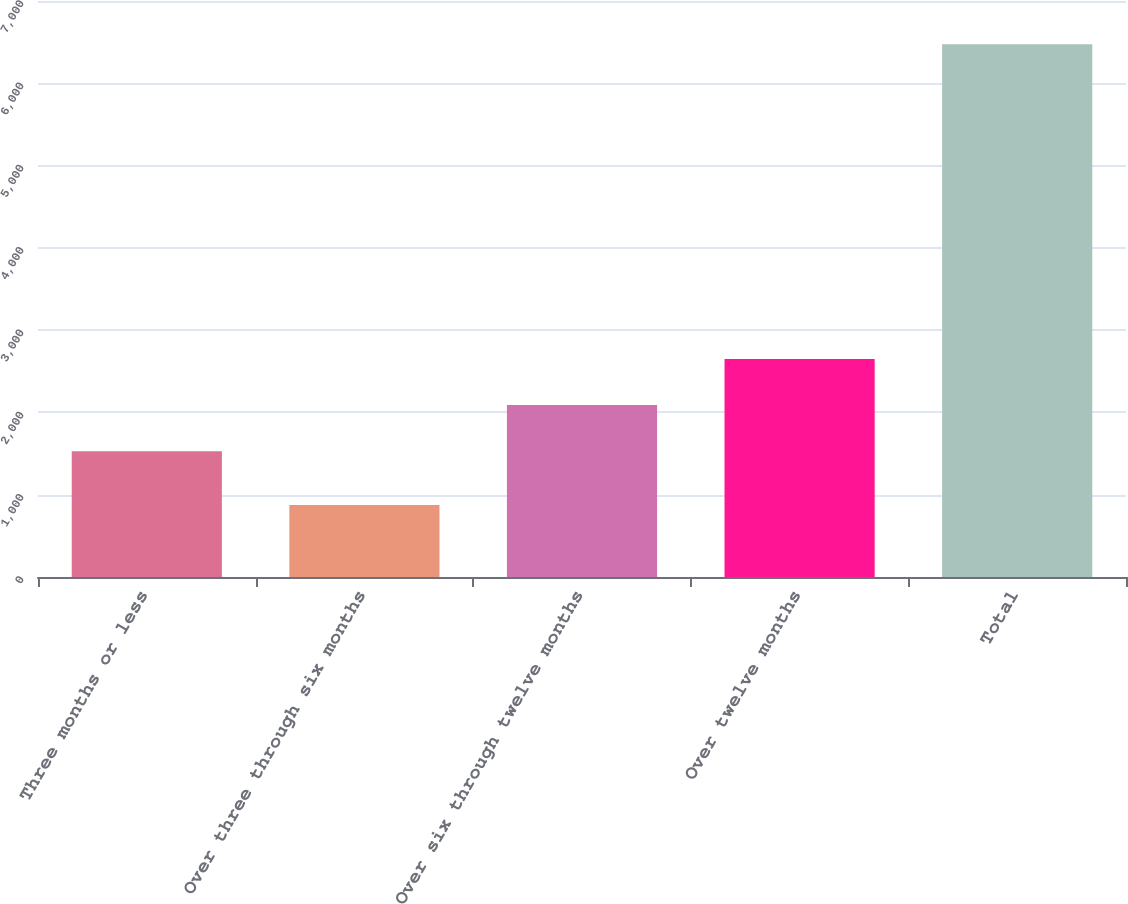Convert chart to OTSL. <chart><loc_0><loc_0><loc_500><loc_500><bar_chart><fcel>Three months or less<fcel>Over three through six months<fcel>Over six through twelve months<fcel>Over twelve months<fcel>Total<nl><fcel>1529<fcel>876<fcel>2088.9<fcel>2648.8<fcel>6475<nl></chart> 